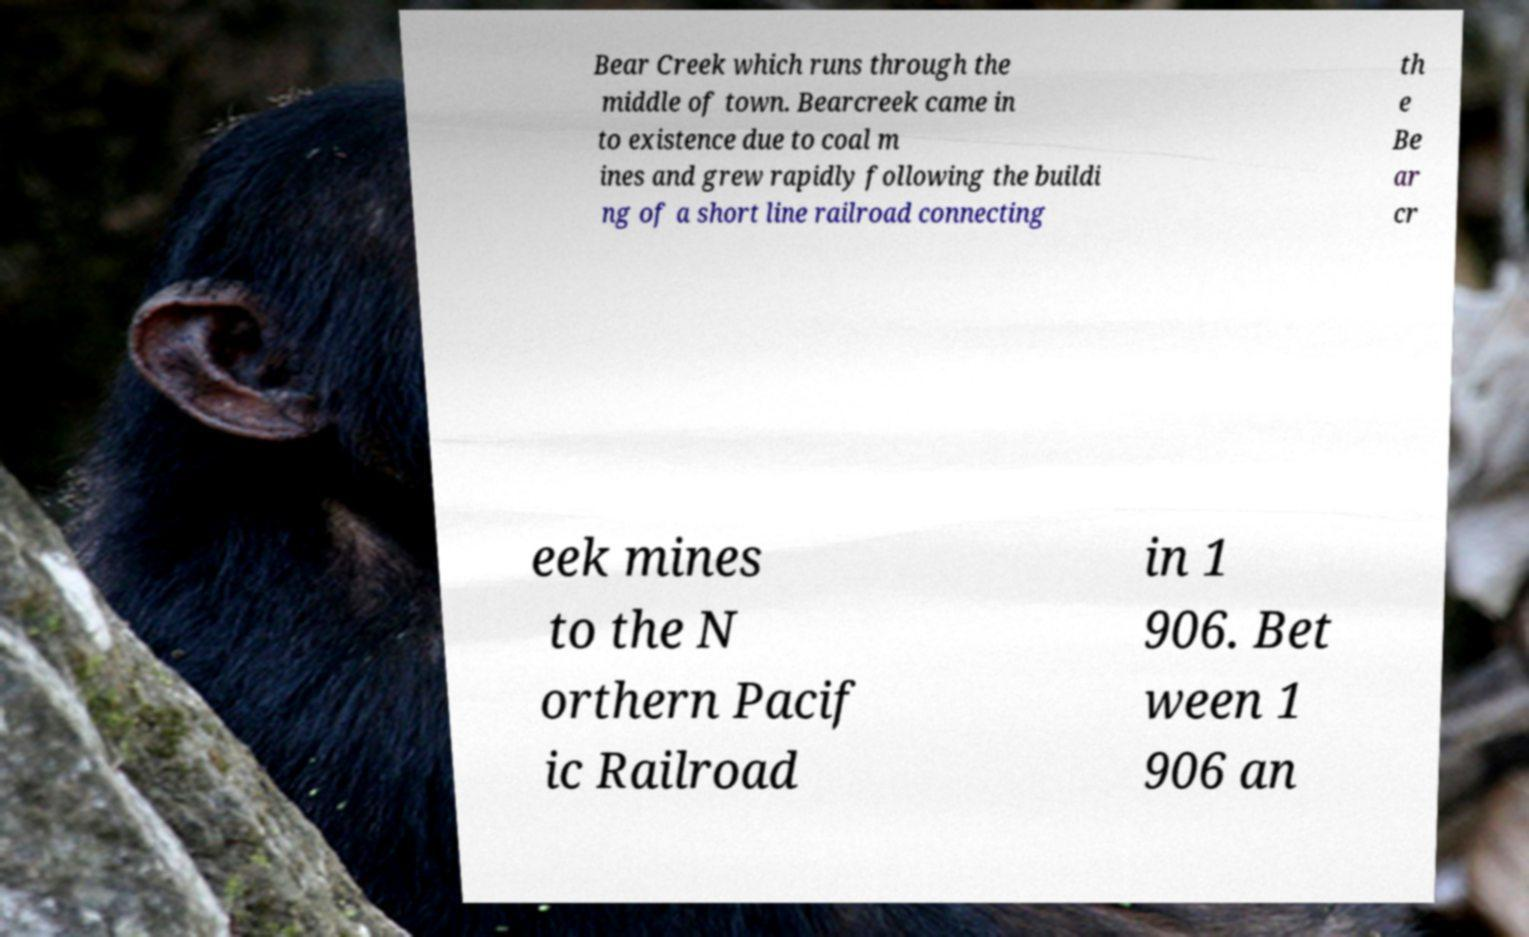There's text embedded in this image that I need extracted. Can you transcribe it verbatim? Bear Creek which runs through the middle of town. Bearcreek came in to existence due to coal m ines and grew rapidly following the buildi ng of a short line railroad connecting th e Be ar cr eek mines to the N orthern Pacif ic Railroad in 1 906. Bet ween 1 906 an 